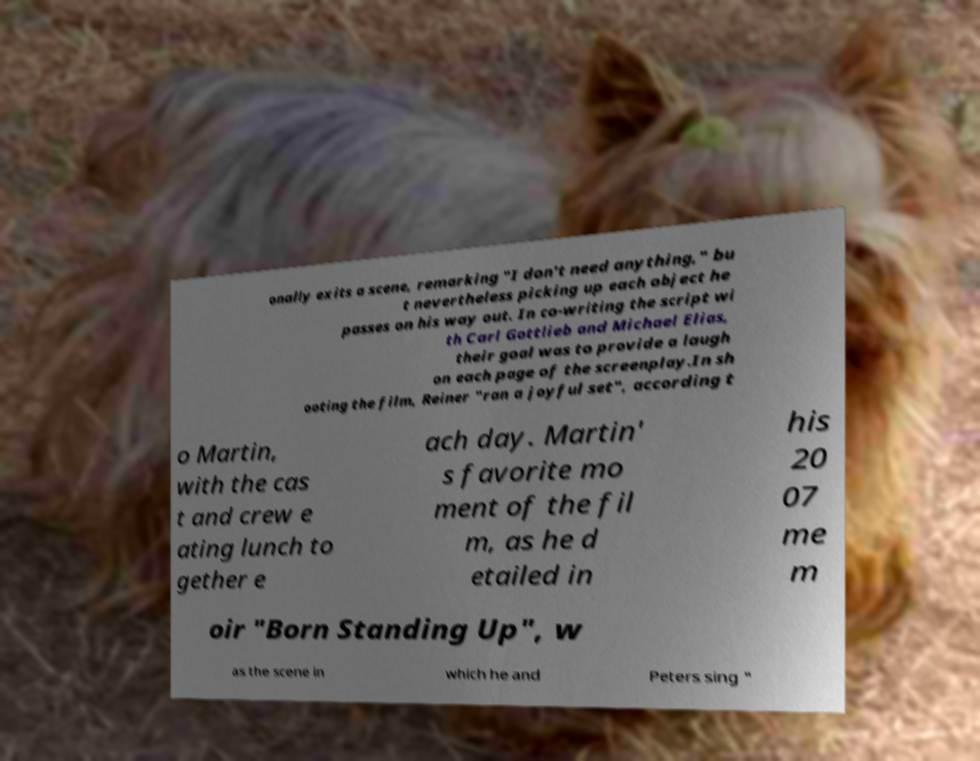Can you read and provide the text displayed in the image?This photo seems to have some interesting text. Can you extract and type it out for me? onally exits a scene, remarking "I don't need anything," bu t nevertheless picking up each object he passes on his way out. In co-writing the script wi th Carl Gottlieb and Michael Elias, their goal was to provide a laugh on each page of the screenplay.In sh ooting the film, Reiner "ran a joyful set", according t o Martin, with the cas t and crew e ating lunch to gether e ach day. Martin' s favorite mo ment of the fil m, as he d etailed in his 20 07 me m oir "Born Standing Up", w as the scene in which he and Peters sing " 